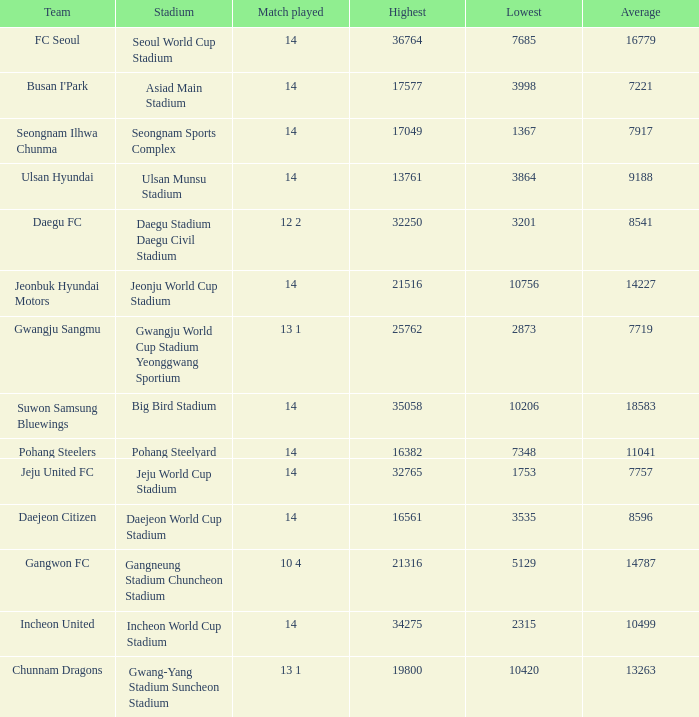What is the highest when pohang steelers is the team? 16382.0. 